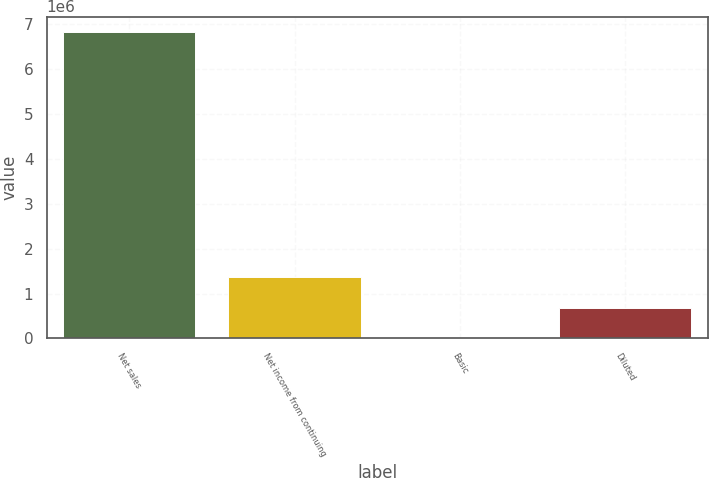<chart> <loc_0><loc_0><loc_500><loc_500><bar_chart><fcel>Net sales<fcel>Net income from continuing<fcel>Basic<fcel>Diluted<nl><fcel>6.82246e+06<fcel>1.36449e+06<fcel>1.53<fcel>682248<nl></chart> 